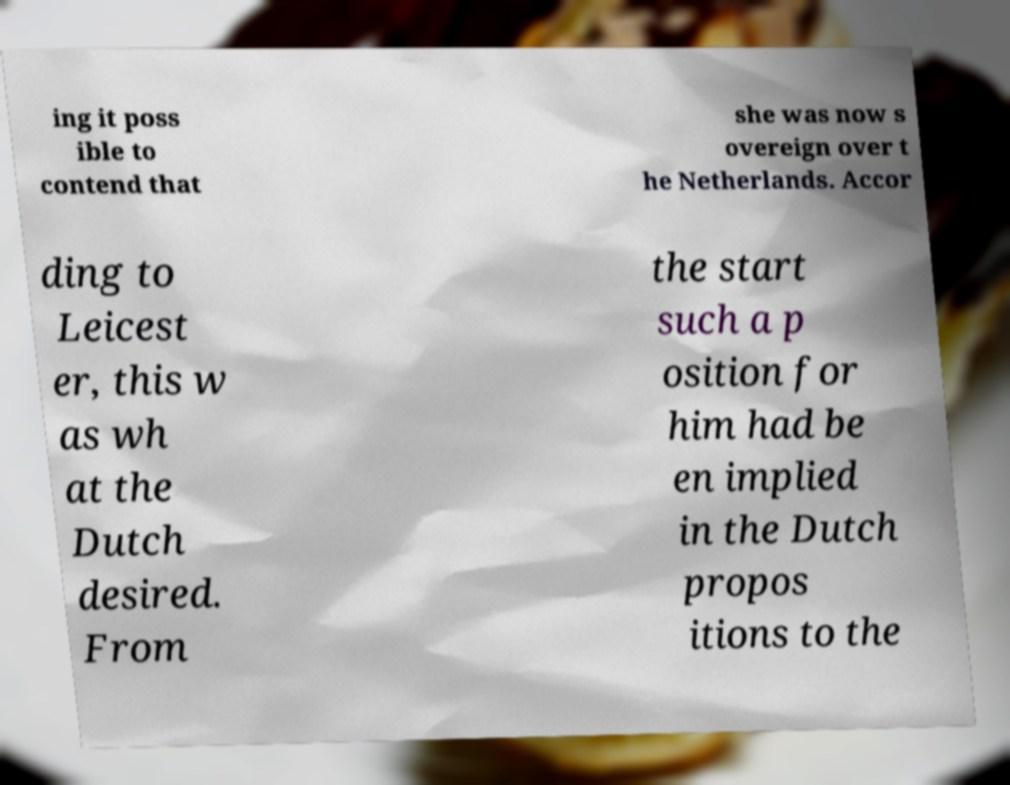Please read and relay the text visible in this image. What does it say? ing it poss ible to contend that she was now s overeign over t he Netherlands. Accor ding to Leicest er, this w as wh at the Dutch desired. From the start such a p osition for him had be en implied in the Dutch propos itions to the 